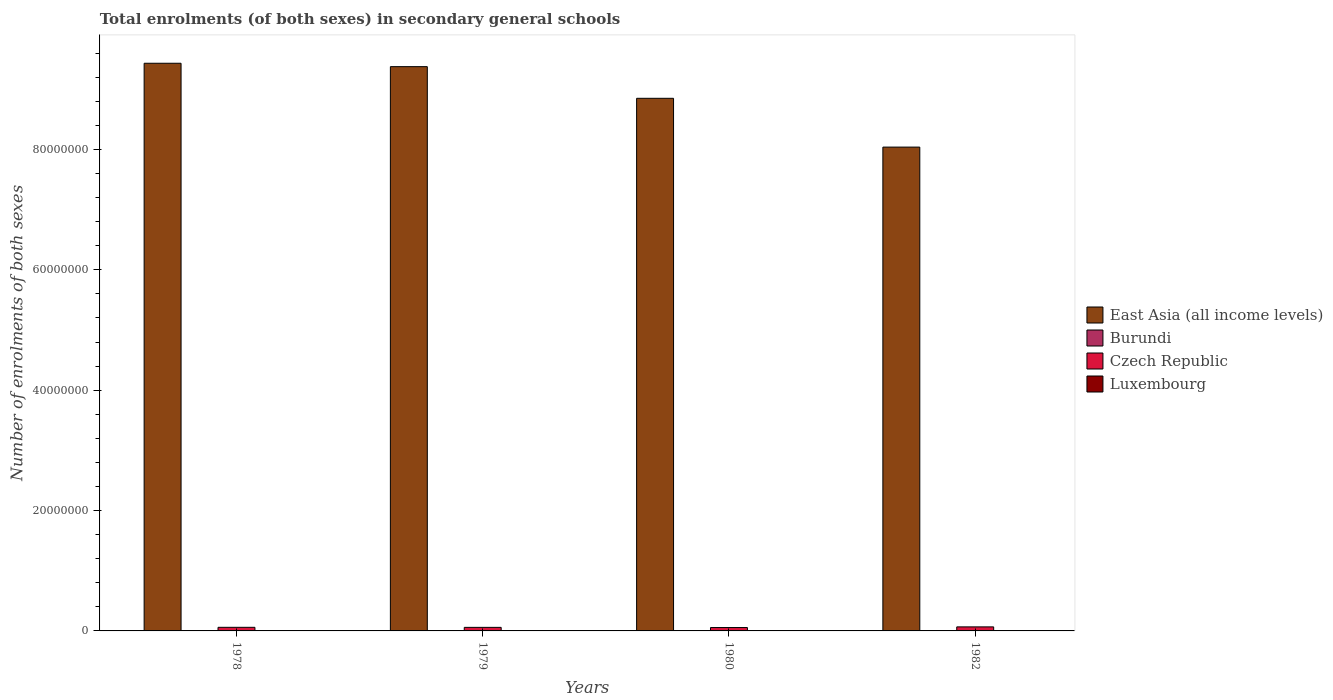What is the label of the 1st group of bars from the left?
Your answer should be very brief. 1978. What is the number of enrolments in secondary schools in East Asia (all income levels) in 1979?
Offer a terse response. 9.38e+07. Across all years, what is the maximum number of enrolments in secondary schools in Luxembourg?
Your answer should be compact. 1.72e+04. Across all years, what is the minimum number of enrolments in secondary schools in Luxembourg?
Ensure brevity in your answer.  9080. In which year was the number of enrolments in secondary schools in East Asia (all income levels) maximum?
Offer a terse response. 1978. What is the total number of enrolments in secondary schools in East Asia (all income levels) in the graph?
Ensure brevity in your answer.  3.57e+08. What is the difference between the number of enrolments in secondary schools in Burundi in 1980 and that in 1982?
Your answer should be compact. -2542. What is the difference between the number of enrolments in secondary schools in Czech Republic in 1982 and the number of enrolments in secondary schools in Luxembourg in 1978?
Offer a very short reply. 6.54e+05. What is the average number of enrolments in secondary schools in Czech Republic per year?
Your answer should be very brief. 6.06e+05. In the year 1978, what is the difference between the number of enrolments in secondary schools in Burundi and number of enrolments in secondary schools in Luxembourg?
Offer a very short reply. -9192. What is the ratio of the number of enrolments in secondary schools in Czech Republic in 1978 to that in 1979?
Offer a very short reply. 1.02. Is the number of enrolments in secondary schools in Luxembourg in 1979 less than that in 1980?
Your answer should be compact. Yes. What is the difference between the highest and the second highest number of enrolments in secondary schools in Burundi?
Make the answer very short. 2542. What is the difference between the highest and the lowest number of enrolments in secondary schools in Luxembourg?
Your answer should be compact. 8097. In how many years, is the number of enrolments in secondary schools in East Asia (all income levels) greater than the average number of enrolments in secondary schools in East Asia (all income levels) taken over all years?
Keep it short and to the point. 2. What does the 4th bar from the left in 1978 represents?
Offer a terse response. Luxembourg. What does the 4th bar from the right in 1982 represents?
Provide a short and direct response. East Asia (all income levels). How many bars are there?
Offer a very short reply. 16. Does the graph contain any zero values?
Give a very brief answer. No. Does the graph contain grids?
Your answer should be very brief. No. Where does the legend appear in the graph?
Offer a terse response. Center right. How many legend labels are there?
Provide a succinct answer. 4. What is the title of the graph?
Provide a short and direct response. Total enrolments (of both sexes) in secondary general schools. What is the label or title of the Y-axis?
Keep it short and to the point. Number of enrolments of both sexes. What is the Number of enrolments of both sexes of East Asia (all income levels) in 1978?
Your answer should be compact. 9.43e+07. What is the Number of enrolments of both sexes in Burundi in 1978?
Provide a short and direct response. 7398. What is the Number of enrolments of both sexes in Czech Republic in 1978?
Offer a very short reply. 5.99e+05. What is the Number of enrolments of both sexes in Luxembourg in 1978?
Keep it short and to the point. 1.66e+04. What is the Number of enrolments of both sexes in East Asia (all income levels) in 1979?
Provide a succinct answer. 9.38e+07. What is the Number of enrolments of both sexes of Burundi in 1979?
Give a very brief answer. 7872. What is the Number of enrolments of both sexes of Czech Republic in 1979?
Provide a short and direct response. 5.90e+05. What is the Number of enrolments of both sexes in Luxembourg in 1979?
Offer a terse response. 1.66e+04. What is the Number of enrolments of both sexes in East Asia (all income levels) in 1980?
Give a very brief answer. 8.85e+07. What is the Number of enrolments of both sexes of Burundi in 1980?
Ensure brevity in your answer.  7967. What is the Number of enrolments of both sexes of Czech Republic in 1980?
Provide a short and direct response. 5.63e+05. What is the Number of enrolments of both sexes of Luxembourg in 1980?
Offer a very short reply. 1.72e+04. What is the Number of enrolments of both sexes of East Asia (all income levels) in 1982?
Ensure brevity in your answer.  8.04e+07. What is the Number of enrolments of both sexes in Burundi in 1982?
Make the answer very short. 1.05e+04. What is the Number of enrolments of both sexes of Czech Republic in 1982?
Offer a terse response. 6.71e+05. What is the Number of enrolments of both sexes of Luxembourg in 1982?
Your response must be concise. 9080. Across all years, what is the maximum Number of enrolments of both sexes in East Asia (all income levels)?
Offer a terse response. 9.43e+07. Across all years, what is the maximum Number of enrolments of both sexes in Burundi?
Provide a short and direct response. 1.05e+04. Across all years, what is the maximum Number of enrolments of both sexes in Czech Republic?
Offer a terse response. 6.71e+05. Across all years, what is the maximum Number of enrolments of both sexes in Luxembourg?
Offer a very short reply. 1.72e+04. Across all years, what is the minimum Number of enrolments of both sexes in East Asia (all income levels)?
Keep it short and to the point. 8.04e+07. Across all years, what is the minimum Number of enrolments of both sexes in Burundi?
Keep it short and to the point. 7398. Across all years, what is the minimum Number of enrolments of both sexes in Czech Republic?
Offer a very short reply. 5.63e+05. Across all years, what is the minimum Number of enrolments of both sexes in Luxembourg?
Keep it short and to the point. 9080. What is the total Number of enrolments of both sexes of East Asia (all income levels) in the graph?
Make the answer very short. 3.57e+08. What is the total Number of enrolments of both sexes of Burundi in the graph?
Give a very brief answer. 3.37e+04. What is the total Number of enrolments of both sexes of Czech Republic in the graph?
Your answer should be very brief. 2.42e+06. What is the total Number of enrolments of both sexes of Luxembourg in the graph?
Make the answer very short. 5.95e+04. What is the difference between the Number of enrolments of both sexes of East Asia (all income levels) in 1978 and that in 1979?
Offer a terse response. 5.64e+05. What is the difference between the Number of enrolments of both sexes of Burundi in 1978 and that in 1979?
Your response must be concise. -474. What is the difference between the Number of enrolments of both sexes of Czech Republic in 1978 and that in 1979?
Your response must be concise. 9068. What is the difference between the Number of enrolments of both sexes of East Asia (all income levels) in 1978 and that in 1980?
Offer a very short reply. 5.82e+06. What is the difference between the Number of enrolments of both sexes in Burundi in 1978 and that in 1980?
Make the answer very short. -569. What is the difference between the Number of enrolments of both sexes of Czech Republic in 1978 and that in 1980?
Give a very brief answer. 3.64e+04. What is the difference between the Number of enrolments of both sexes of Luxembourg in 1978 and that in 1980?
Keep it short and to the point. -587. What is the difference between the Number of enrolments of both sexes of East Asia (all income levels) in 1978 and that in 1982?
Provide a succinct answer. 1.39e+07. What is the difference between the Number of enrolments of both sexes in Burundi in 1978 and that in 1982?
Offer a terse response. -3111. What is the difference between the Number of enrolments of both sexes of Czech Republic in 1978 and that in 1982?
Keep it short and to the point. -7.13e+04. What is the difference between the Number of enrolments of both sexes in Luxembourg in 1978 and that in 1982?
Your response must be concise. 7510. What is the difference between the Number of enrolments of both sexes in East Asia (all income levels) in 1979 and that in 1980?
Provide a succinct answer. 5.26e+06. What is the difference between the Number of enrolments of both sexes of Burundi in 1979 and that in 1980?
Provide a short and direct response. -95. What is the difference between the Number of enrolments of both sexes in Czech Republic in 1979 and that in 1980?
Your answer should be very brief. 2.74e+04. What is the difference between the Number of enrolments of both sexes of Luxembourg in 1979 and that in 1980?
Provide a short and direct response. -572. What is the difference between the Number of enrolments of both sexes in East Asia (all income levels) in 1979 and that in 1982?
Your answer should be compact. 1.34e+07. What is the difference between the Number of enrolments of both sexes of Burundi in 1979 and that in 1982?
Keep it short and to the point. -2637. What is the difference between the Number of enrolments of both sexes of Czech Republic in 1979 and that in 1982?
Keep it short and to the point. -8.04e+04. What is the difference between the Number of enrolments of both sexes in Luxembourg in 1979 and that in 1982?
Offer a terse response. 7525. What is the difference between the Number of enrolments of both sexes in East Asia (all income levels) in 1980 and that in 1982?
Your answer should be very brief. 8.11e+06. What is the difference between the Number of enrolments of both sexes of Burundi in 1980 and that in 1982?
Your response must be concise. -2542. What is the difference between the Number of enrolments of both sexes in Czech Republic in 1980 and that in 1982?
Your response must be concise. -1.08e+05. What is the difference between the Number of enrolments of both sexes of Luxembourg in 1980 and that in 1982?
Make the answer very short. 8097. What is the difference between the Number of enrolments of both sexes in East Asia (all income levels) in 1978 and the Number of enrolments of both sexes in Burundi in 1979?
Your response must be concise. 9.43e+07. What is the difference between the Number of enrolments of both sexes in East Asia (all income levels) in 1978 and the Number of enrolments of both sexes in Czech Republic in 1979?
Provide a short and direct response. 9.37e+07. What is the difference between the Number of enrolments of both sexes of East Asia (all income levels) in 1978 and the Number of enrolments of both sexes of Luxembourg in 1979?
Your answer should be compact. 9.43e+07. What is the difference between the Number of enrolments of both sexes in Burundi in 1978 and the Number of enrolments of both sexes in Czech Republic in 1979?
Ensure brevity in your answer.  -5.83e+05. What is the difference between the Number of enrolments of both sexes of Burundi in 1978 and the Number of enrolments of both sexes of Luxembourg in 1979?
Provide a succinct answer. -9207. What is the difference between the Number of enrolments of both sexes of Czech Republic in 1978 and the Number of enrolments of both sexes of Luxembourg in 1979?
Keep it short and to the point. 5.83e+05. What is the difference between the Number of enrolments of both sexes in East Asia (all income levels) in 1978 and the Number of enrolments of both sexes in Burundi in 1980?
Your response must be concise. 9.43e+07. What is the difference between the Number of enrolments of both sexes of East Asia (all income levels) in 1978 and the Number of enrolments of both sexes of Czech Republic in 1980?
Provide a short and direct response. 9.38e+07. What is the difference between the Number of enrolments of both sexes in East Asia (all income levels) in 1978 and the Number of enrolments of both sexes in Luxembourg in 1980?
Ensure brevity in your answer.  9.43e+07. What is the difference between the Number of enrolments of both sexes in Burundi in 1978 and the Number of enrolments of both sexes in Czech Republic in 1980?
Give a very brief answer. -5.55e+05. What is the difference between the Number of enrolments of both sexes of Burundi in 1978 and the Number of enrolments of both sexes of Luxembourg in 1980?
Your response must be concise. -9779. What is the difference between the Number of enrolments of both sexes of Czech Republic in 1978 and the Number of enrolments of both sexes of Luxembourg in 1980?
Give a very brief answer. 5.82e+05. What is the difference between the Number of enrolments of both sexes in East Asia (all income levels) in 1978 and the Number of enrolments of both sexes in Burundi in 1982?
Offer a terse response. 9.43e+07. What is the difference between the Number of enrolments of both sexes in East Asia (all income levels) in 1978 and the Number of enrolments of both sexes in Czech Republic in 1982?
Offer a terse response. 9.36e+07. What is the difference between the Number of enrolments of both sexes in East Asia (all income levels) in 1978 and the Number of enrolments of both sexes in Luxembourg in 1982?
Make the answer very short. 9.43e+07. What is the difference between the Number of enrolments of both sexes of Burundi in 1978 and the Number of enrolments of both sexes of Czech Republic in 1982?
Your response must be concise. -6.63e+05. What is the difference between the Number of enrolments of both sexes in Burundi in 1978 and the Number of enrolments of both sexes in Luxembourg in 1982?
Your response must be concise. -1682. What is the difference between the Number of enrolments of both sexes of Czech Republic in 1978 and the Number of enrolments of both sexes of Luxembourg in 1982?
Your answer should be very brief. 5.90e+05. What is the difference between the Number of enrolments of both sexes of East Asia (all income levels) in 1979 and the Number of enrolments of both sexes of Burundi in 1980?
Your answer should be very brief. 9.37e+07. What is the difference between the Number of enrolments of both sexes of East Asia (all income levels) in 1979 and the Number of enrolments of both sexes of Czech Republic in 1980?
Provide a succinct answer. 9.32e+07. What is the difference between the Number of enrolments of both sexes in East Asia (all income levels) in 1979 and the Number of enrolments of both sexes in Luxembourg in 1980?
Ensure brevity in your answer.  9.37e+07. What is the difference between the Number of enrolments of both sexes of Burundi in 1979 and the Number of enrolments of both sexes of Czech Republic in 1980?
Your answer should be very brief. -5.55e+05. What is the difference between the Number of enrolments of both sexes of Burundi in 1979 and the Number of enrolments of both sexes of Luxembourg in 1980?
Provide a short and direct response. -9305. What is the difference between the Number of enrolments of both sexes of Czech Republic in 1979 and the Number of enrolments of both sexes of Luxembourg in 1980?
Keep it short and to the point. 5.73e+05. What is the difference between the Number of enrolments of both sexes of East Asia (all income levels) in 1979 and the Number of enrolments of both sexes of Burundi in 1982?
Your answer should be compact. 9.37e+07. What is the difference between the Number of enrolments of both sexes in East Asia (all income levels) in 1979 and the Number of enrolments of both sexes in Czech Republic in 1982?
Give a very brief answer. 9.31e+07. What is the difference between the Number of enrolments of both sexes of East Asia (all income levels) in 1979 and the Number of enrolments of both sexes of Luxembourg in 1982?
Provide a short and direct response. 9.37e+07. What is the difference between the Number of enrolments of both sexes in Burundi in 1979 and the Number of enrolments of both sexes in Czech Republic in 1982?
Provide a succinct answer. -6.63e+05. What is the difference between the Number of enrolments of both sexes in Burundi in 1979 and the Number of enrolments of both sexes in Luxembourg in 1982?
Offer a very short reply. -1208. What is the difference between the Number of enrolments of both sexes of Czech Republic in 1979 and the Number of enrolments of both sexes of Luxembourg in 1982?
Offer a very short reply. 5.81e+05. What is the difference between the Number of enrolments of both sexes of East Asia (all income levels) in 1980 and the Number of enrolments of both sexes of Burundi in 1982?
Provide a succinct answer. 8.85e+07. What is the difference between the Number of enrolments of both sexes of East Asia (all income levels) in 1980 and the Number of enrolments of both sexes of Czech Republic in 1982?
Offer a terse response. 8.78e+07. What is the difference between the Number of enrolments of both sexes in East Asia (all income levels) in 1980 and the Number of enrolments of both sexes in Luxembourg in 1982?
Make the answer very short. 8.85e+07. What is the difference between the Number of enrolments of both sexes of Burundi in 1980 and the Number of enrolments of both sexes of Czech Republic in 1982?
Provide a succinct answer. -6.63e+05. What is the difference between the Number of enrolments of both sexes of Burundi in 1980 and the Number of enrolments of both sexes of Luxembourg in 1982?
Give a very brief answer. -1113. What is the difference between the Number of enrolments of both sexes in Czech Republic in 1980 and the Number of enrolments of both sexes in Luxembourg in 1982?
Offer a very short reply. 5.54e+05. What is the average Number of enrolments of both sexes in East Asia (all income levels) per year?
Your answer should be very brief. 8.92e+07. What is the average Number of enrolments of both sexes of Burundi per year?
Offer a terse response. 8436.5. What is the average Number of enrolments of both sexes in Czech Republic per year?
Your response must be concise. 6.06e+05. What is the average Number of enrolments of both sexes of Luxembourg per year?
Make the answer very short. 1.49e+04. In the year 1978, what is the difference between the Number of enrolments of both sexes in East Asia (all income levels) and Number of enrolments of both sexes in Burundi?
Your answer should be very brief. 9.43e+07. In the year 1978, what is the difference between the Number of enrolments of both sexes in East Asia (all income levels) and Number of enrolments of both sexes in Czech Republic?
Provide a succinct answer. 9.37e+07. In the year 1978, what is the difference between the Number of enrolments of both sexes of East Asia (all income levels) and Number of enrolments of both sexes of Luxembourg?
Your answer should be very brief. 9.43e+07. In the year 1978, what is the difference between the Number of enrolments of both sexes in Burundi and Number of enrolments of both sexes in Czech Republic?
Ensure brevity in your answer.  -5.92e+05. In the year 1978, what is the difference between the Number of enrolments of both sexes in Burundi and Number of enrolments of both sexes in Luxembourg?
Offer a very short reply. -9192. In the year 1978, what is the difference between the Number of enrolments of both sexes in Czech Republic and Number of enrolments of both sexes in Luxembourg?
Your answer should be compact. 5.83e+05. In the year 1979, what is the difference between the Number of enrolments of both sexes in East Asia (all income levels) and Number of enrolments of both sexes in Burundi?
Provide a succinct answer. 9.37e+07. In the year 1979, what is the difference between the Number of enrolments of both sexes of East Asia (all income levels) and Number of enrolments of both sexes of Czech Republic?
Keep it short and to the point. 9.32e+07. In the year 1979, what is the difference between the Number of enrolments of both sexes of East Asia (all income levels) and Number of enrolments of both sexes of Luxembourg?
Your answer should be compact. 9.37e+07. In the year 1979, what is the difference between the Number of enrolments of both sexes in Burundi and Number of enrolments of both sexes in Czech Republic?
Provide a succinct answer. -5.82e+05. In the year 1979, what is the difference between the Number of enrolments of both sexes of Burundi and Number of enrolments of both sexes of Luxembourg?
Offer a very short reply. -8733. In the year 1979, what is the difference between the Number of enrolments of both sexes of Czech Republic and Number of enrolments of both sexes of Luxembourg?
Offer a very short reply. 5.74e+05. In the year 1980, what is the difference between the Number of enrolments of both sexes in East Asia (all income levels) and Number of enrolments of both sexes in Burundi?
Provide a short and direct response. 8.85e+07. In the year 1980, what is the difference between the Number of enrolments of both sexes in East Asia (all income levels) and Number of enrolments of both sexes in Czech Republic?
Your answer should be compact. 8.79e+07. In the year 1980, what is the difference between the Number of enrolments of both sexes of East Asia (all income levels) and Number of enrolments of both sexes of Luxembourg?
Give a very brief answer. 8.85e+07. In the year 1980, what is the difference between the Number of enrolments of both sexes of Burundi and Number of enrolments of both sexes of Czech Republic?
Your answer should be very brief. -5.55e+05. In the year 1980, what is the difference between the Number of enrolments of both sexes of Burundi and Number of enrolments of both sexes of Luxembourg?
Keep it short and to the point. -9210. In the year 1980, what is the difference between the Number of enrolments of both sexes in Czech Republic and Number of enrolments of both sexes in Luxembourg?
Keep it short and to the point. 5.46e+05. In the year 1982, what is the difference between the Number of enrolments of both sexes in East Asia (all income levels) and Number of enrolments of both sexes in Burundi?
Keep it short and to the point. 8.04e+07. In the year 1982, what is the difference between the Number of enrolments of both sexes of East Asia (all income levels) and Number of enrolments of both sexes of Czech Republic?
Offer a terse response. 7.97e+07. In the year 1982, what is the difference between the Number of enrolments of both sexes in East Asia (all income levels) and Number of enrolments of both sexes in Luxembourg?
Make the answer very short. 8.04e+07. In the year 1982, what is the difference between the Number of enrolments of both sexes in Burundi and Number of enrolments of both sexes in Czech Republic?
Keep it short and to the point. -6.60e+05. In the year 1982, what is the difference between the Number of enrolments of both sexes in Burundi and Number of enrolments of both sexes in Luxembourg?
Offer a very short reply. 1429. In the year 1982, what is the difference between the Number of enrolments of both sexes in Czech Republic and Number of enrolments of both sexes in Luxembourg?
Give a very brief answer. 6.62e+05. What is the ratio of the Number of enrolments of both sexes in Burundi in 1978 to that in 1979?
Make the answer very short. 0.94. What is the ratio of the Number of enrolments of both sexes in Czech Republic in 1978 to that in 1979?
Your response must be concise. 1.02. What is the ratio of the Number of enrolments of both sexes of Luxembourg in 1978 to that in 1979?
Offer a very short reply. 1. What is the ratio of the Number of enrolments of both sexes in East Asia (all income levels) in 1978 to that in 1980?
Provide a short and direct response. 1.07. What is the ratio of the Number of enrolments of both sexes of Czech Republic in 1978 to that in 1980?
Give a very brief answer. 1.06. What is the ratio of the Number of enrolments of both sexes of Luxembourg in 1978 to that in 1980?
Provide a succinct answer. 0.97. What is the ratio of the Number of enrolments of both sexes of East Asia (all income levels) in 1978 to that in 1982?
Keep it short and to the point. 1.17. What is the ratio of the Number of enrolments of both sexes of Burundi in 1978 to that in 1982?
Your answer should be very brief. 0.7. What is the ratio of the Number of enrolments of both sexes in Czech Republic in 1978 to that in 1982?
Your response must be concise. 0.89. What is the ratio of the Number of enrolments of both sexes of Luxembourg in 1978 to that in 1982?
Keep it short and to the point. 1.83. What is the ratio of the Number of enrolments of both sexes in East Asia (all income levels) in 1979 to that in 1980?
Offer a very short reply. 1.06. What is the ratio of the Number of enrolments of both sexes in Burundi in 1979 to that in 1980?
Your answer should be very brief. 0.99. What is the ratio of the Number of enrolments of both sexes of Czech Republic in 1979 to that in 1980?
Offer a very short reply. 1.05. What is the ratio of the Number of enrolments of both sexes in Luxembourg in 1979 to that in 1980?
Give a very brief answer. 0.97. What is the ratio of the Number of enrolments of both sexes of East Asia (all income levels) in 1979 to that in 1982?
Make the answer very short. 1.17. What is the ratio of the Number of enrolments of both sexes in Burundi in 1979 to that in 1982?
Ensure brevity in your answer.  0.75. What is the ratio of the Number of enrolments of both sexes of Czech Republic in 1979 to that in 1982?
Provide a succinct answer. 0.88. What is the ratio of the Number of enrolments of both sexes in Luxembourg in 1979 to that in 1982?
Give a very brief answer. 1.83. What is the ratio of the Number of enrolments of both sexes in East Asia (all income levels) in 1980 to that in 1982?
Your answer should be compact. 1.1. What is the ratio of the Number of enrolments of both sexes in Burundi in 1980 to that in 1982?
Your response must be concise. 0.76. What is the ratio of the Number of enrolments of both sexes of Czech Republic in 1980 to that in 1982?
Ensure brevity in your answer.  0.84. What is the ratio of the Number of enrolments of both sexes of Luxembourg in 1980 to that in 1982?
Offer a very short reply. 1.89. What is the difference between the highest and the second highest Number of enrolments of both sexes in East Asia (all income levels)?
Offer a terse response. 5.64e+05. What is the difference between the highest and the second highest Number of enrolments of both sexes of Burundi?
Ensure brevity in your answer.  2542. What is the difference between the highest and the second highest Number of enrolments of both sexes in Czech Republic?
Your answer should be very brief. 7.13e+04. What is the difference between the highest and the second highest Number of enrolments of both sexes in Luxembourg?
Your response must be concise. 572. What is the difference between the highest and the lowest Number of enrolments of both sexes in East Asia (all income levels)?
Give a very brief answer. 1.39e+07. What is the difference between the highest and the lowest Number of enrolments of both sexes in Burundi?
Ensure brevity in your answer.  3111. What is the difference between the highest and the lowest Number of enrolments of both sexes in Czech Republic?
Keep it short and to the point. 1.08e+05. What is the difference between the highest and the lowest Number of enrolments of both sexes in Luxembourg?
Give a very brief answer. 8097. 